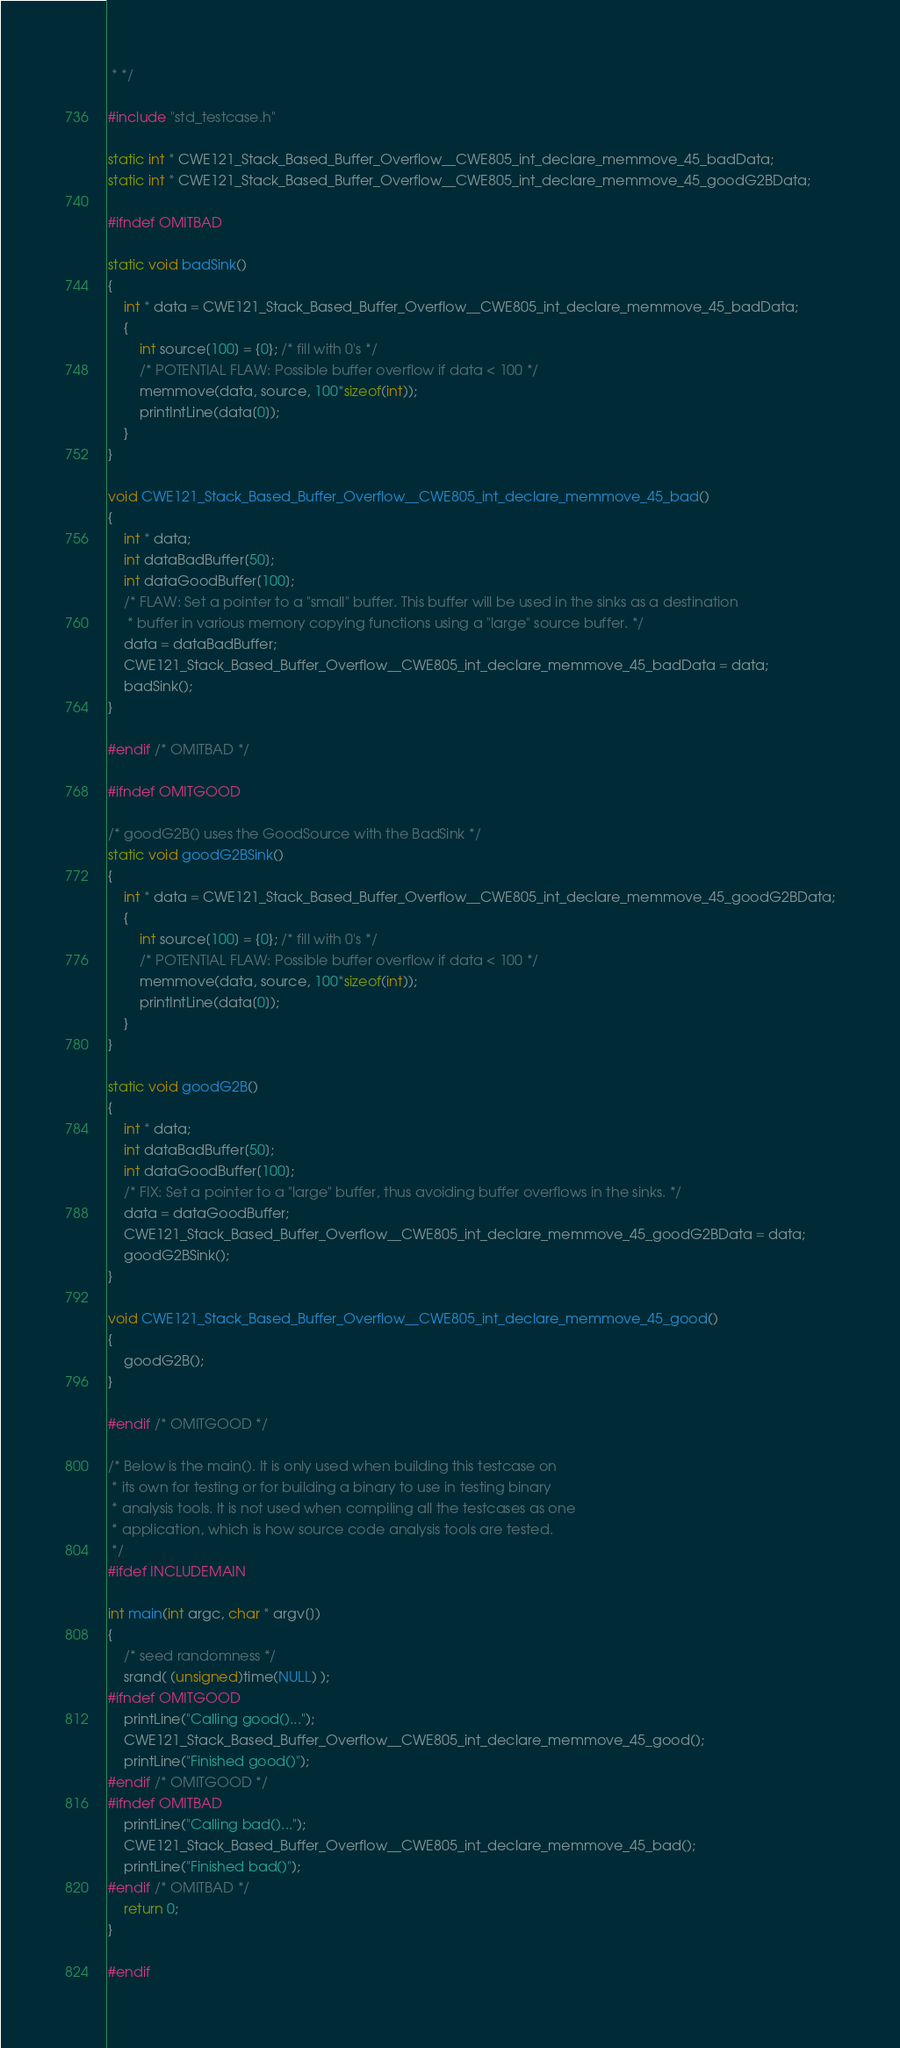Convert code to text. <code><loc_0><loc_0><loc_500><loc_500><_C_> * */

#include "std_testcase.h"

static int * CWE121_Stack_Based_Buffer_Overflow__CWE805_int_declare_memmove_45_badData;
static int * CWE121_Stack_Based_Buffer_Overflow__CWE805_int_declare_memmove_45_goodG2BData;

#ifndef OMITBAD

static void badSink()
{
    int * data = CWE121_Stack_Based_Buffer_Overflow__CWE805_int_declare_memmove_45_badData;
    {
        int source[100] = {0}; /* fill with 0's */
        /* POTENTIAL FLAW: Possible buffer overflow if data < 100 */
        memmove(data, source, 100*sizeof(int));
        printIntLine(data[0]);
    }
}

void CWE121_Stack_Based_Buffer_Overflow__CWE805_int_declare_memmove_45_bad()
{
    int * data;
    int dataBadBuffer[50];
    int dataGoodBuffer[100];
    /* FLAW: Set a pointer to a "small" buffer. This buffer will be used in the sinks as a destination
     * buffer in various memory copying functions using a "large" source buffer. */
    data = dataBadBuffer;
    CWE121_Stack_Based_Buffer_Overflow__CWE805_int_declare_memmove_45_badData = data;
    badSink();
}

#endif /* OMITBAD */

#ifndef OMITGOOD

/* goodG2B() uses the GoodSource with the BadSink */
static void goodG2BSink()
{
    int * data = CWE121_Stack_Based_Buffer_Overflow__CWE805_int_declare_memmove_45_goodG2BData;
    {
        int source[100] = {0}; /* fill with 0's */
        /* POTENTIAL FLAW: Possible buffer overflow if data < 100 */
        memmove(data, source, 100*sizeof(int));
        printIntLine(data[0]);
    }
}

static void goodG2B()
{
    int * data;
    int dataBadBuffer[50];
    int dataGoodBuffer[100];
    /* FIX: Set a pointer to a "large" buffer, thus avoiding buffer overflows in the sinks. */
    data = dataGoodBuffer;
    CWE121_Stack_Based_Buffer_Overflow__CWE805_int_declare_memmove_45_goodG2BData = data;
    goodG2BSink();
}

void CWE121_Stack_Based_Buffer_Overflow__CWE805_int_declare_memmove_45_good()
{
    goodG2B();
}

#endif /* OMITGOOD */

/* Below is the main(). It is only used when building this testcase on
 * its own for testing or for building a binary to use in testing binary
 * analysis tools. It is not used when compiling all the testcases as one
 * application, which is how source code analysis tools are tested.
 */
#ifdef INCLUDEMAIN

int main(int argc, char * argv[])
{
    /* seed randomness */
    srand( (unsigned)time(NULL) );
#ifndef OMITGOOD
    printLine("Calling good()...");
    CWE121_Stack_Based_Buffer_Overflow__CWE805_int_declare_memmove_45_good();
    printLine("Finished good()");
#endif /* OMITGOOD */
#ifndef OMITBAD
    printLine("Calling bad()...");
    CWE121_Stack_Based_Buffer_Overflow__CWE805_int_declare_memmove_45_bad();
    printLine("Finished bad()");
#endif /* OMITBAD */
    return 0;
}

#endif
</code> 